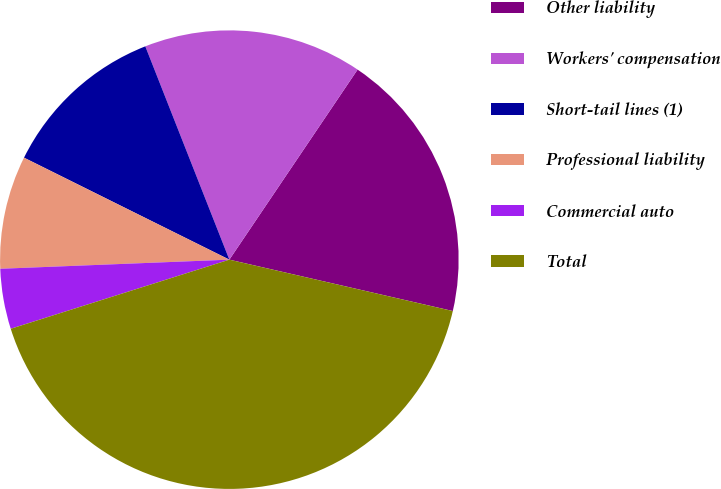<chart> <loc_0><loc_0><loc_500><loc_500><pie_chart><fcel>Other liability<fcel>Workers' compensation<fcel>Short-tail lines (1)<fcel>Professional liability<fcel>Commercial auto<fcel>Total<nl><fcel>19.15%<fcel>15.42%<fcel>11.69%<fcel>7.97%<fcel>4.24%<fcel>41.53%<nl></chart> 